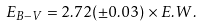Convert formula to latex. <formula><loc_0><loc_0><loc_500><loc_500>E _ { B - V } = 2 . 7 2 ( \pm 0 . 0 3 ) \times E . W .</formula> 